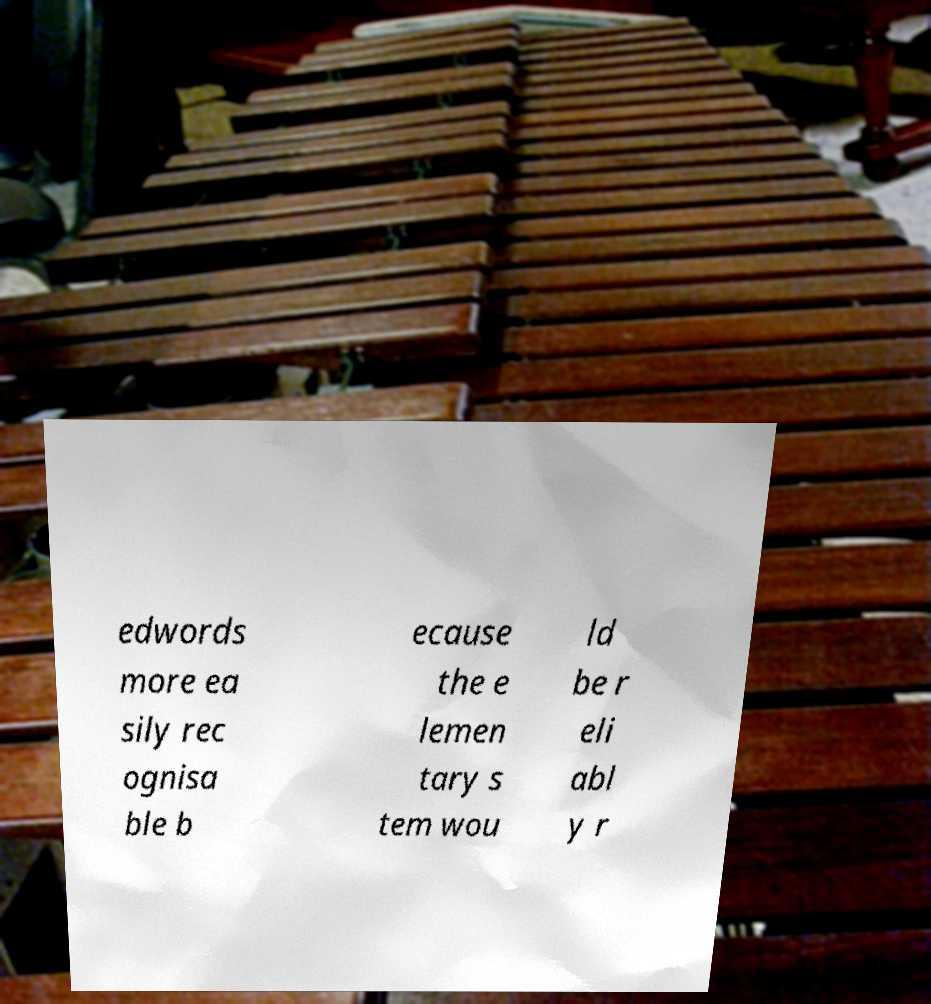What messages or text are displayed in this image? I need them in a readable, typed format. edwords more ea sily rec ognisa ble b ecause the e lemen tary s tem wou ld be r eli abl y r 